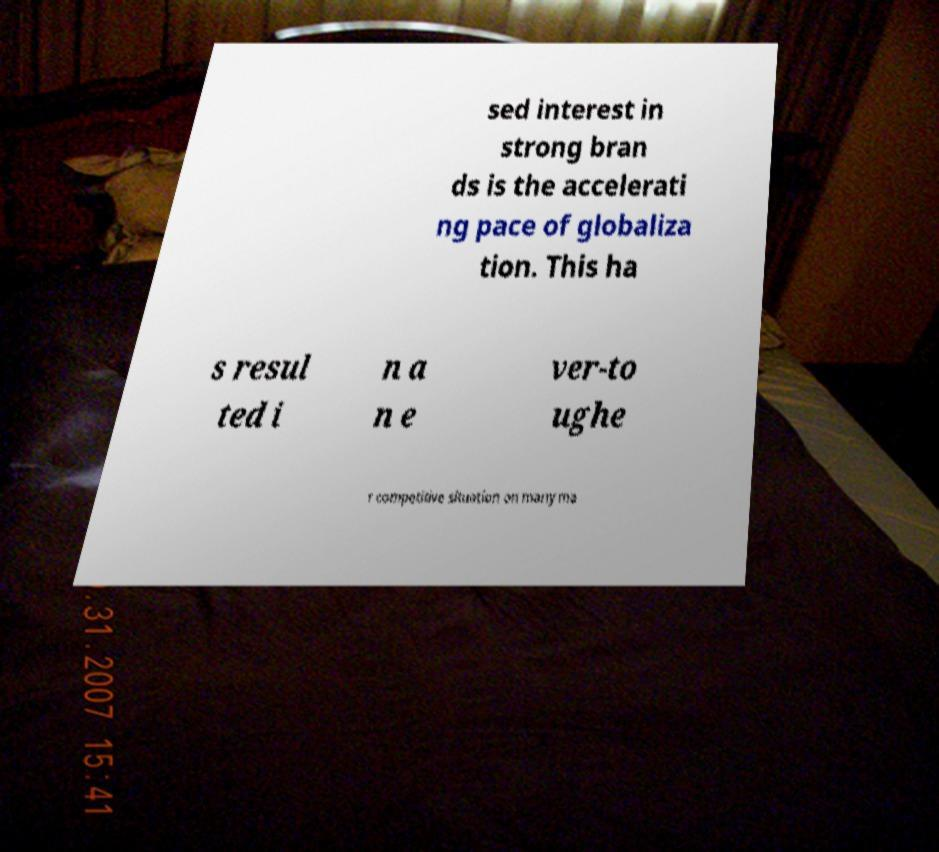Can you read and provide the text displayed in the image?This photo seems to have some interesting text. Can you extract and type it out for me? sed interest in strong bran ds is the accelerati ng pace of globaliza tion. This ha s resul ted i n a n e ver-to ughe r competitive situation on many ma 